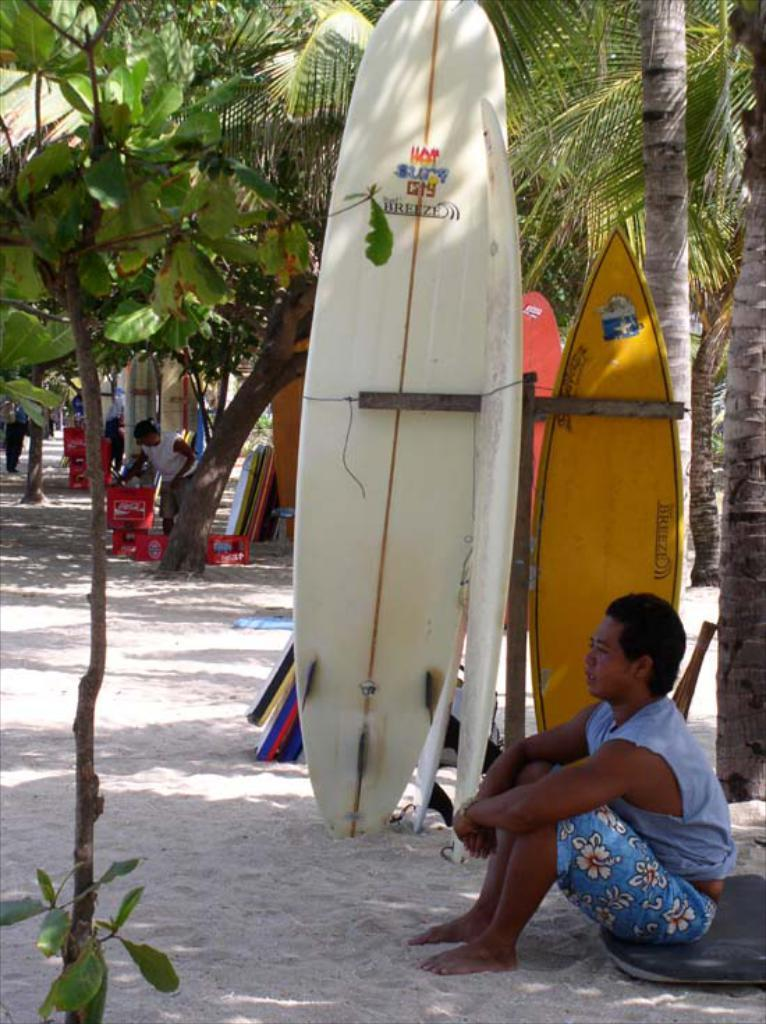What is the person in the image doing? There is a person sitting in the image. What is the person wearing? The person is wearing clothes. What type of environment is depicted in the image? There is sand, trees, and water visible in the image. What objects are present in the image that might be used for recreational activities? There are water boards in the image. What other objects can be seen in the image? There is a container in the image. Are there any other people in the image? Yes, there are other people in the image. What note is the person playing on a musical instrument in the image? There is no musical instrument or note present in the image. What type of school can be seen in the background of the image? There is no school visible in the image. 